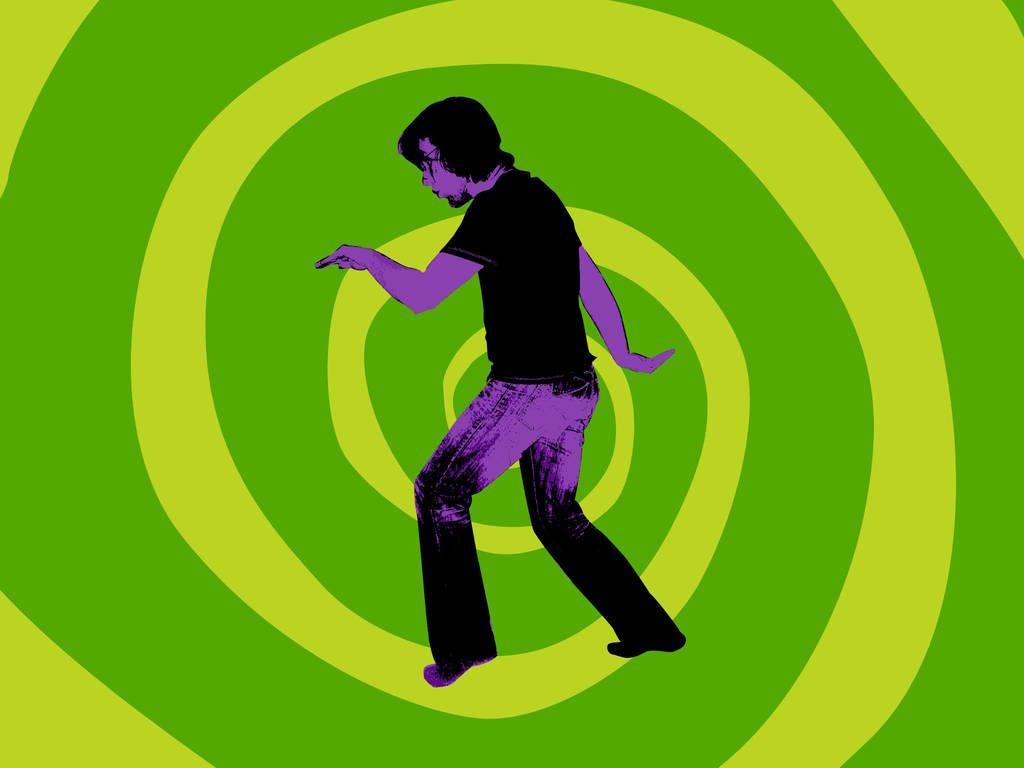What type of image is being described? The image is animated. Can you describe the person in the image? There is a person standing in the image. What color is the background of the image? The background of the image is green. What type of art is being displayed on the record in the image? There is no record present in the image, so it is not possible to determine what type of art might be displayed on it. 